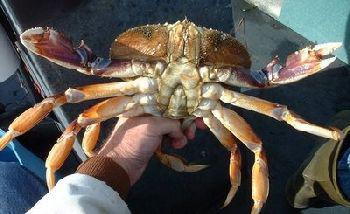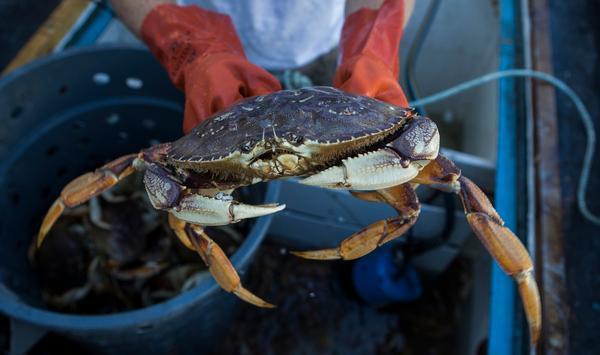The first image is the image on the left, the second image is the image on the right. Given the left and right images, does the statement "Each image includes a hand holding up a crab, and at least one image shows a bare hand, and at least one image shows the crab facing the camera." hold true? Answer yes or no. Yes. The first image is the image on the left, the second image is the image on the right. For the images displayed, is the sentence "In every image, there is a human holding a crab." factually correct? Answer yes or no. Yes. 